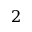Convert formula to latex. <formula><loc_0><loc_0><loc_500><loc_500>\mathsf i t { 2 }</formula> 